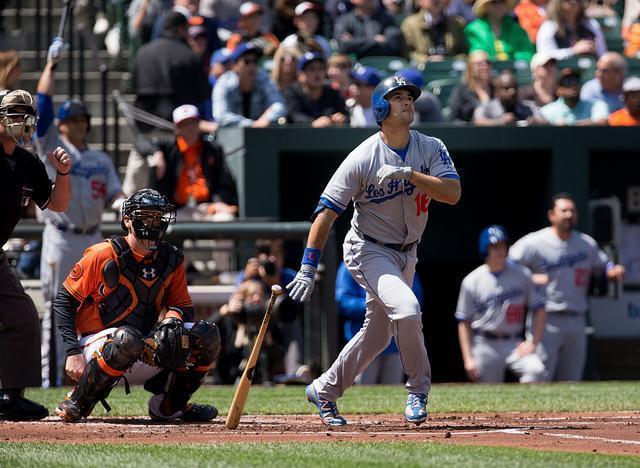How many people are there?
Give a very brief answer. 13. How many giraffes are there?
Give a very brief answer. 0. 